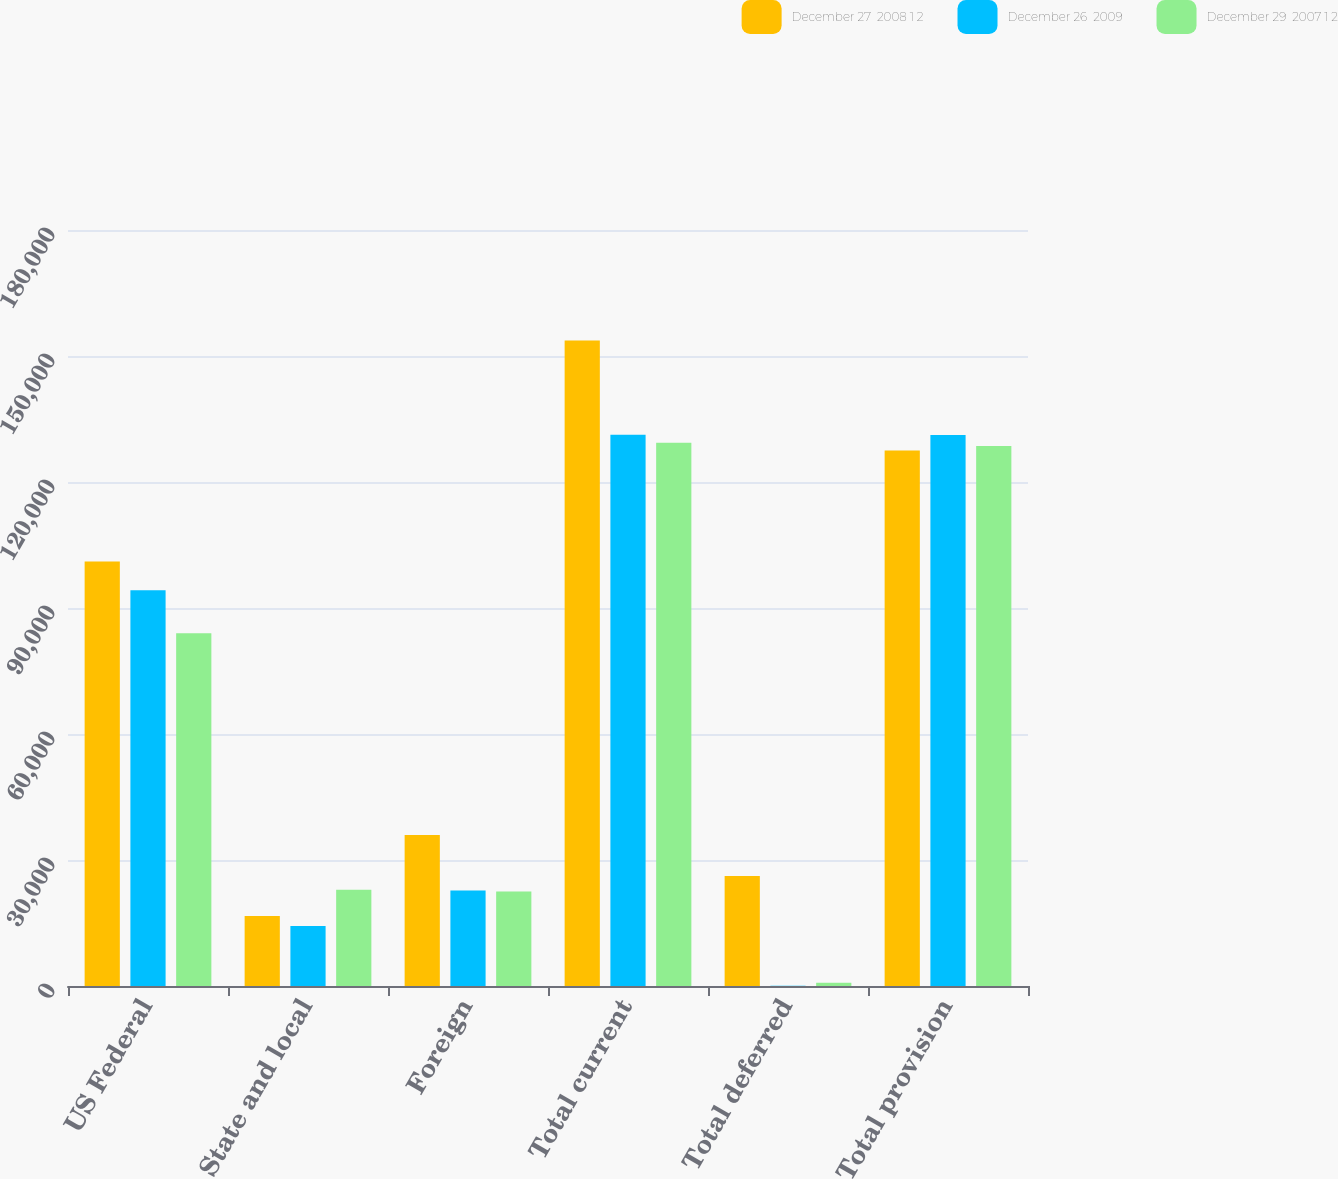Convert chart to OTSL. <chart><loc_0><loc_0><loc_500><loc_500><stacked_bar_chart><ecel><fcel>US Federal<fcel>State and local<fcel>Foreign<fcel>Total current<fcel>Total deferred<fcel>Total provision<nl><fcel>December 27  2008 1 2<fcel>101092<fcel>16649<fcel>35965<fcel>153706<fcel>26185<fcel>127521<nl><fcel>December 26  2009<fcel>94215<fcel>14310<fcel>22741<fcel>131266<fcel>56<fcel>131210<nl><fcel>December 29  2007 1 2<fcel>83971<fcel>22907<fcel>22478<fcel>129356<fcel>800<fcel>128556<nl></chart> 